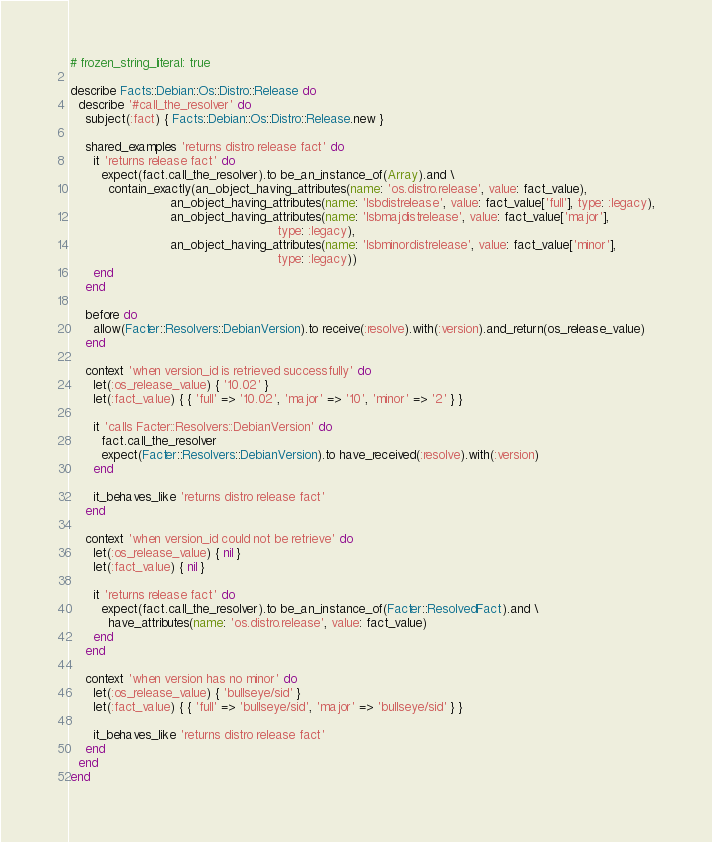<code> <loc_0><loc_0><loc_500><loc_500><_Ruby_># frozen_string_literal: true

describe Facts::Debian::Os::Distro::Release do
  describe '#call_the_resolver' do
    subject(:fact) { Facts::Debian::Os::Distro::Release.new }

    shared_examples 'returns distro release fact' do
      it 'returns release fact' do
        expect(fact.call_the_resolver).to be_an_instance_of(Array).and \
          contain_exactly(an_object_having_attributes(name: 'os.distro.release', value: fact_value),
                          an_object_having_attributes(name: 'lsbdistrelease', value: fact_value['full'], type: :legacy),
                          an_object_having_attributes(name: 'lsbmajdistrelease', value: fact_value['major'],
                                                      type: :legacy),
                          an_object_having_attributes(name: 'lsbminordistrelease', value: fact_value['minor'],
                                                      type: :legacy))
      end
    end

    before do
      allow(Facter::Resolvers::DebianVersion).to receive(:resolve).with(:version).and_return(os_release_value)
    end

    context 'when version_id is retrieved successfully' do
      let(:os_release_value) { '10.02' }
      let(:fact_value) { { 'full' => '10.02', 'major' => '10', 'minor' => '2' } }

      it 'calls Facter::Resolvers::DebianVersion' do
        fact.call_the_resolver
        expect(Facter::Resolvers::DebianVersion).to have_received(:resolve).with(:version)
      end

      it_behaves_like 'returns distro release fact'
    end

    context 'when version_id could not be retrieve' do
      let(:os_release_value) { nil }
      let(:fact_value) { nil }

      it 'returns release fact' do
        expect(fact.call_the_resolver).to be_an_instance_of(Facter::ResolvedFact).and \
          have_attributes(name: 'os.distro.release', value: fact_value)
      end
    end

    context 'when version has no minor' do
      let(:os_release_value) { 'bullseye/sid' }
      let(:fact_value) { { 'full' => 'bullseye/sid', 'major' => 'bullseye/sid' } }

      it_behaves_like 'returns distro release fact'
    end
  end
end
</code> 